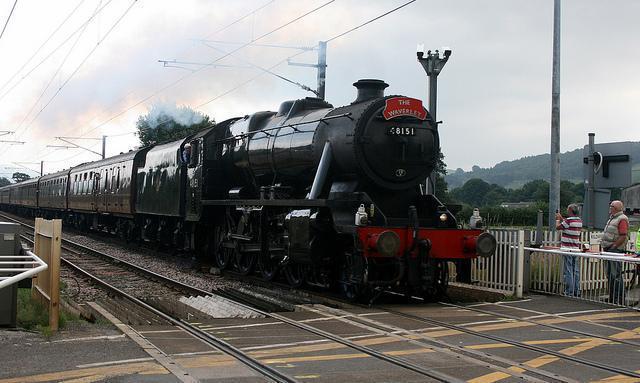How many people in the photo?
Give a very brief answer. 2. How many faces of the clock can you see completely?
Give a very brief answer. 0. 